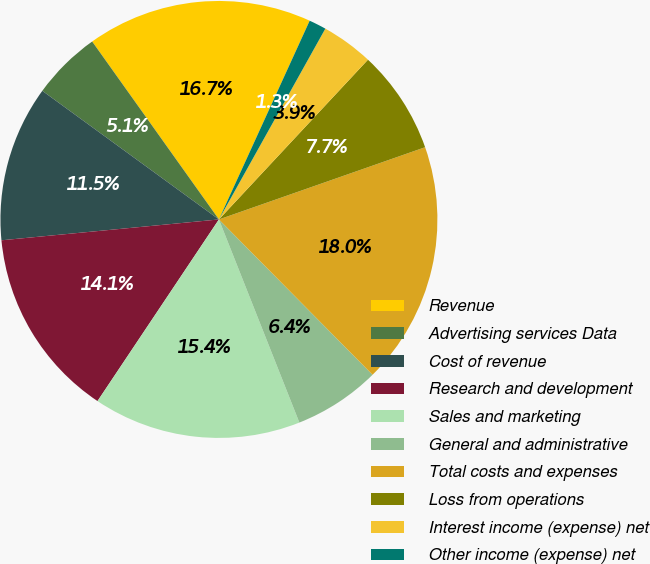<chart> <loc_0><loc_0><loc_500><loc_500><pie_chart><fcel>Revenue<fcel>Advertising services Data<fcel>Cost of revenue<fcel>Research and development<fcel>Sales and marketing<fcel>General and administrative<fcel>Total costs and expenses<fcel>Loss from operations<fcel>Interest income (expense) net<fcel>Other income (expense) net<nl><fcel>16.67%<fcel>5.13%<fcel>11.54%<fcel>14.1%<fcel>15.38%<fcel>6.41%<fcel>17.95%<fcel>7.69%<fcel>3.85%<fcel>1.28%<nl></chart> 